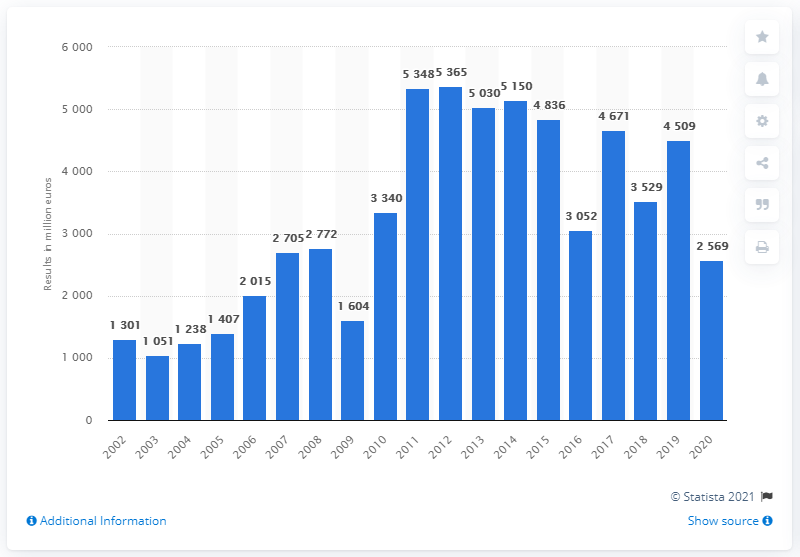Specify some key components in this picture. Audi's operating profit ended in the year 2020. In the fiscal year of 2002, Audi was founded. 